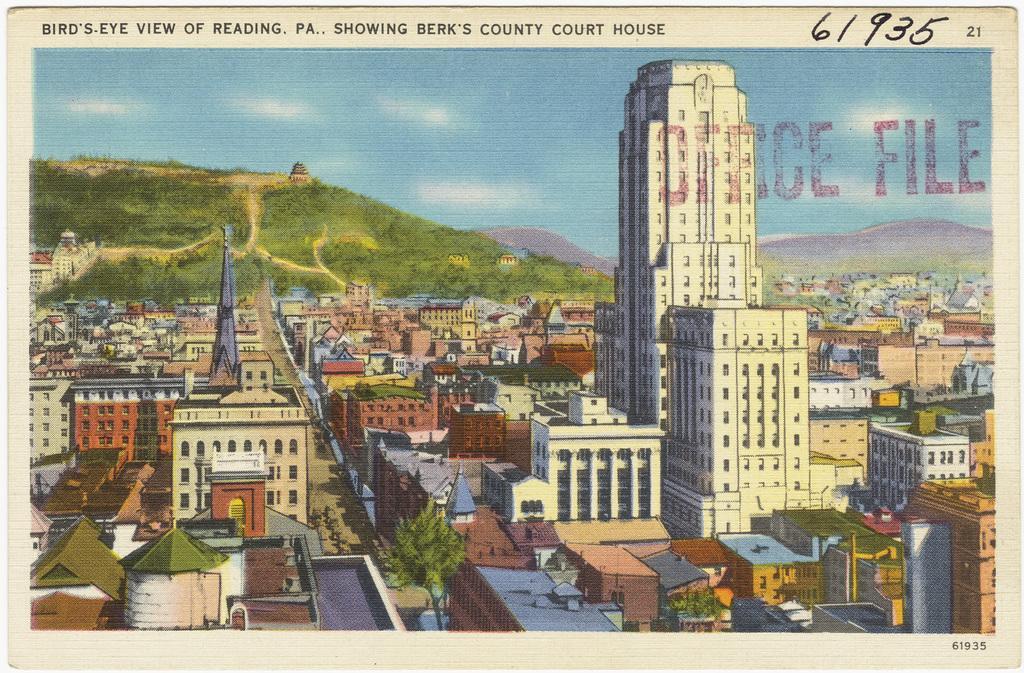Could you give a brief overview of what you see in this image? In this image we can see an image of a paper. In the paper, we can see a painting of a group of buildings. Behind the buildings we can see mountains. At the top we can see the sky. At the top of the image we can see some text. 